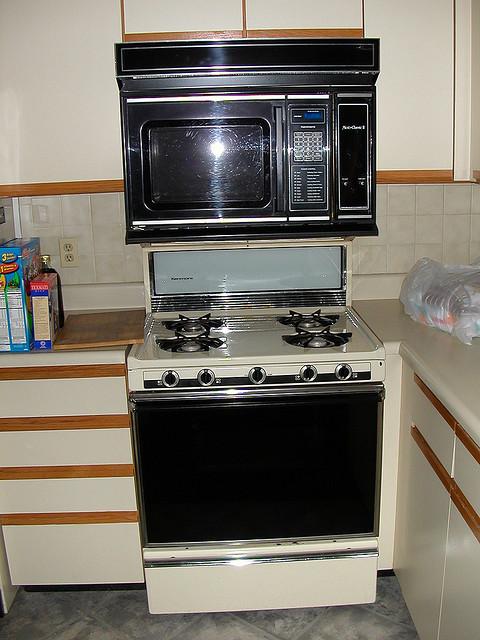Is the stove in use?
Give a very brief answer. No. Are the borders ugly?
Give a very brief answer. Yes. What room is this?
Give a very brief answer. Kitchen. Is this oven stainless steel?
Short answer required. No. 